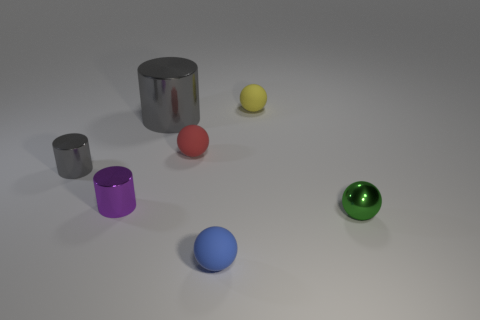Subtract all large metal cylinders. How many cylinders are left? 2 Add 3 large brown shiny cubes. How many objects exist? 10 Subtract 1 cylinders. How many cylinders are left? 2 Subtract all blue balls. How many balls are left? 3 Subtract all gray spheres. Subtract all yellow cylinders. How many spheres are left? 4 Subtract all balls. How many objects are left? 3 Add 1 small yellow spheres. How many small yellow spheres are left? 2 Add 2 big metallic cylinders. How many big metallic cylinders exist? 3 Subtract 0 green cubes. How many objects are left? 7 Subtract all purple rubber cylinders. Subtract all tiny red objects. How many objects are left? 6 